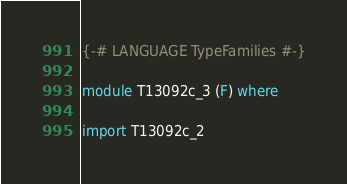<code> <loc_0><loc_0><loc_500><loc_500><_Haskell_>{-# LANGUAGE TypeFamilies #-}

module T13092c_3 (F) where

import T13092c_2
</code> 